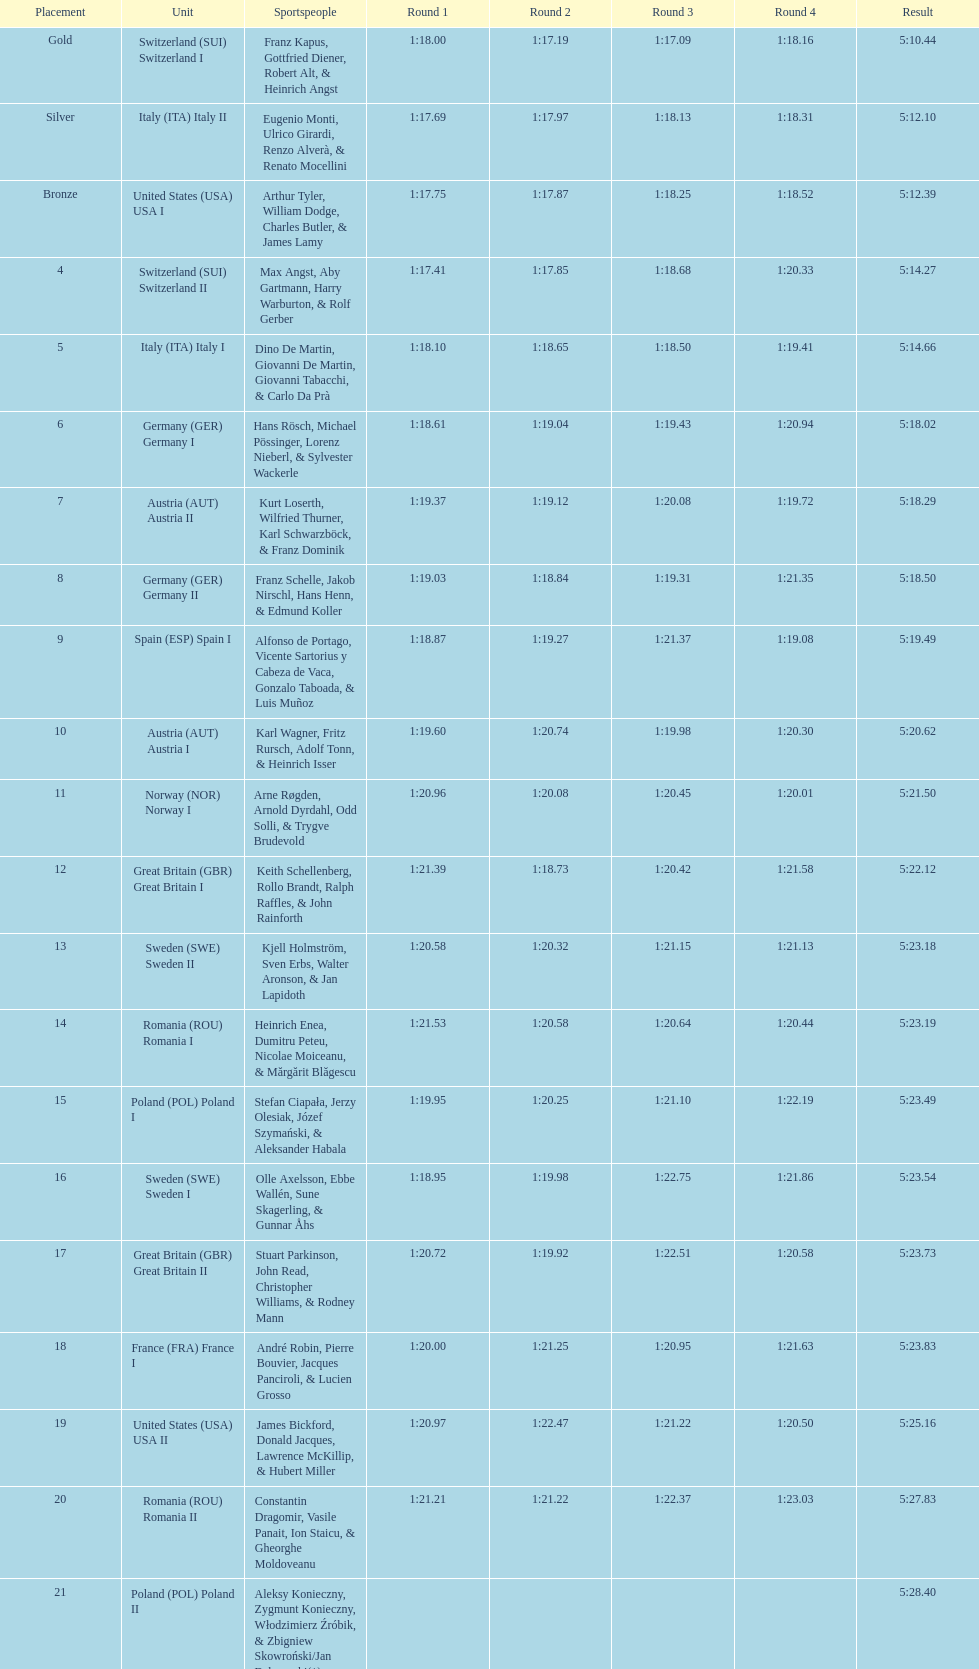What team came in second to last place? Romania. 